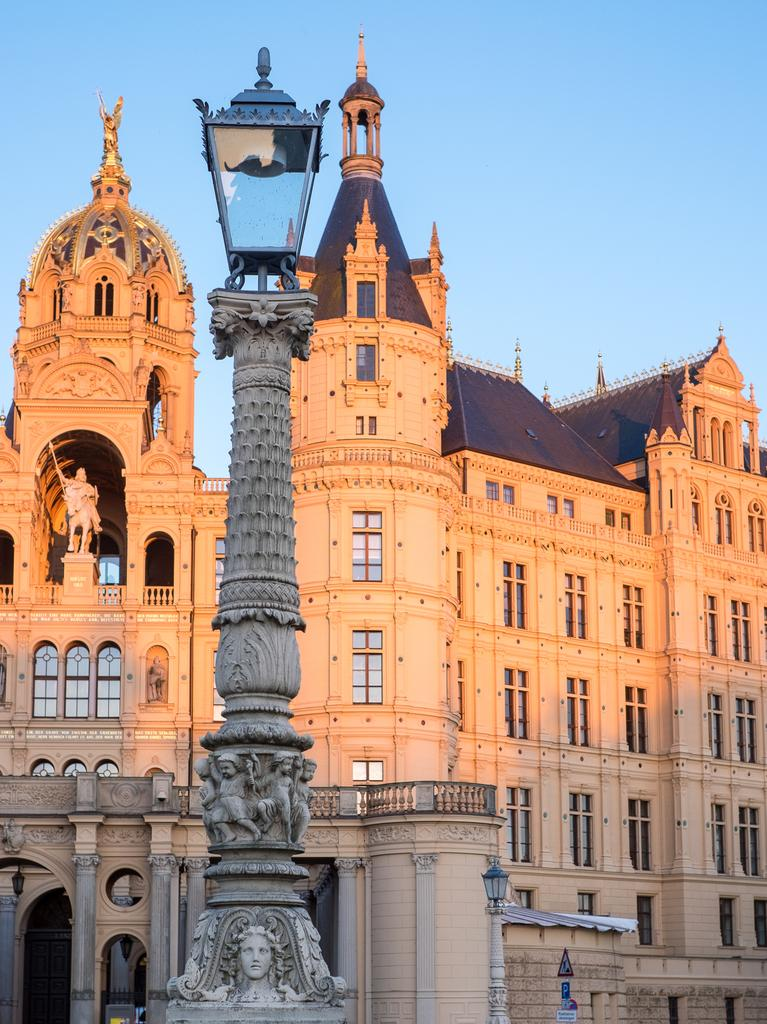What type of building is visible in the image? There is a building with glass windows in the image. What other object can be seen in the image? There is a statue in the image. What type of lighting is present in the image? There are street lamps in the image. How are the street lamps mounted? The street lamps are on stone carving poles. What type of beast can be seen transporting people at the end of the street in the image? There is no beast or transportation depicted in the image; it only features a building, a statue, street lamps, and stone carving poles. 